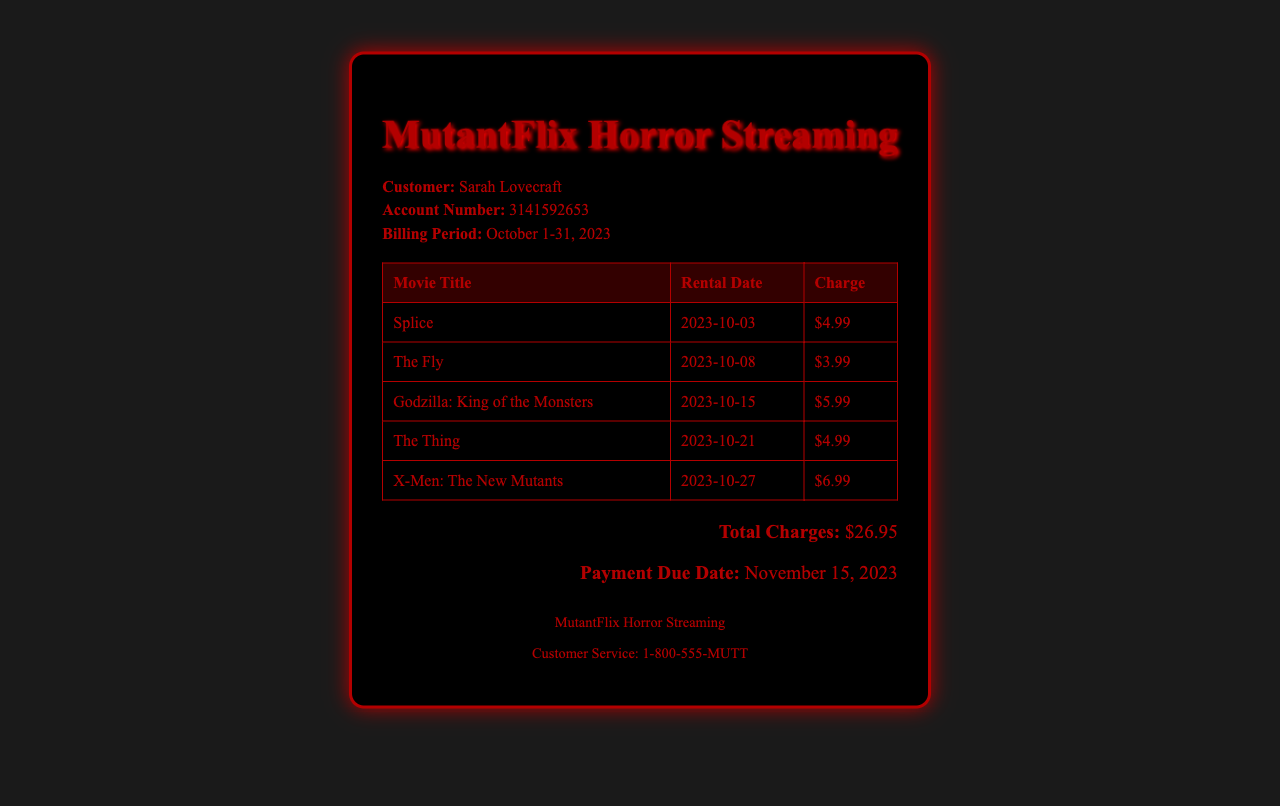What is the customer's name? The document provides information about the customer, which is included in the top section as "Sarah Lovecraft."
Answer: Sarah Lovecraft What is the account number? The account number is specified in the document where it shows "Account Number: 3141592653."
Answer: 3141592653 How many movies were rented? By counting the entries in the table, it can be determined that five movies are listed.
Answer: 5 What is the rental charge for "The Fly"? The document specifies the charge for "The Fly," which is included in the table.
Answer: $3.99 What is the total charge amount? The total charge amount is clearly stated at the bottom of the document as "Total Charges: $26.95."
Answer: $26.95 When is the payment due date? The document mentions the payment due date, indicated in the total charges section.
Answer: November 15, 2023 What was the rental date for "Godzilla: King of the Monsters"? The rental date is provided in the table alongside the movie title, detailing when it was rented.
Answer: 2023-10-15 Which movie has the highest rental charge? By comparing the charges listed for each movie in the table, "X-Men: The New Mutants" has the highest charge.
Answer: $6.99 How many movies feature genetic mutations in this bill? Reviewing the titles, at least four movies specifically relate to genetic mutations.
Answer: 4 